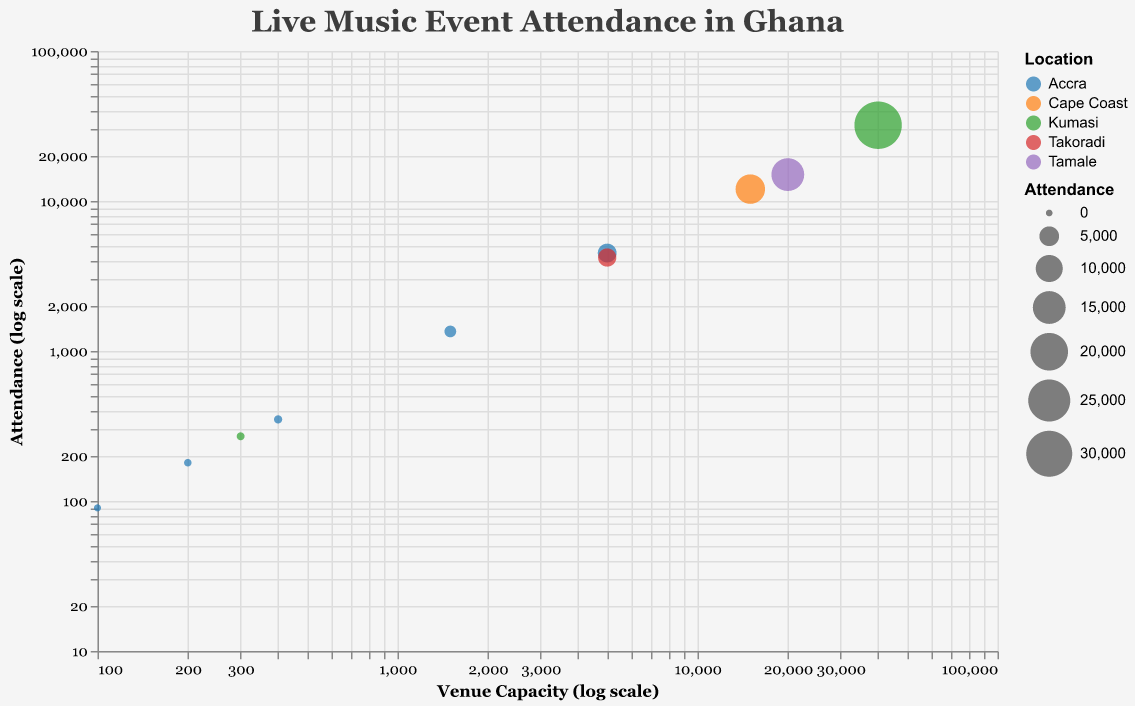Which venue has the highest attendance? The venue with the highest attendance is the one with the largest bubble size and highest position on the vertical axis. This is the Baba Yara Sports Stadium in Kumasi.
Answer: Baba Yara Sports Stadium What is the title of the chart? The title of the chart is displayed at the top center of the figure.
Answer: Live Music Event Attendance in Ghana Which location has the most venues represented in the chart? The color indicates the location. By counting the different colors, we see that Accra has the most venues.
Answer: Accra Which venues in Accra have an attendance greater than 1000? To find this, look at the points within the "Accra" color label and check their y-axis values. The points representing venues in Accra with attendance greater than 1000 are National Theatre Accra and Fantasy Dome.
Answer: National Theatre Accra, Fantasy Dome What is the difference in attendance between Fantasy Dome and Takoradi Jubilee Park? The attendance of Fantasy Dome is 4500 and Takoradi Jubilee Park is 4200. Subtracting 4200 from 4500 gives us 300.
Answer: 300 Which venue has a capacity of exactly 5000? By checking the x-axis values, the venue with a capacity of exactly 5000 is Fantasy Dome in Accra and Takoradi Jubilee Park in Takoradi.
Answer: Fantasy Dome, Takoradi Jubilee Park What is the ratio of attendance to capacity for Cape Coast Sports Stadium? The Cape Coast Sports Stadium has an attendance of 12000 and a capacity of 15000. The ratio is 12000 / 15000 = 0.8.
Answer: 0.8 Which venue in Tamale is represented in the chart, and what is its attendance? The color label for Tamale indicates the venue in Tamale, which is Tamale Sports Stadium. Its attendance is 15000.
Answer: Tamale Sports Stadium, 15000 Which two venues have nearly equal attendance but different capacities? By comparing bubble sizes and capacities, National Theatre Accra (attendance 1350) and Labadi Beach Hotel (attendance 350) have nearly different capacities but not equal attendance. Therefore, this is not the answer. Instead, we see that Fantasy Dome (attendance 4500) and Takoradi Jubilee Park (attendance 4200) have mostly equal attendance.
Answer: Fantasy Dome, Takoradi Jubilee Park 